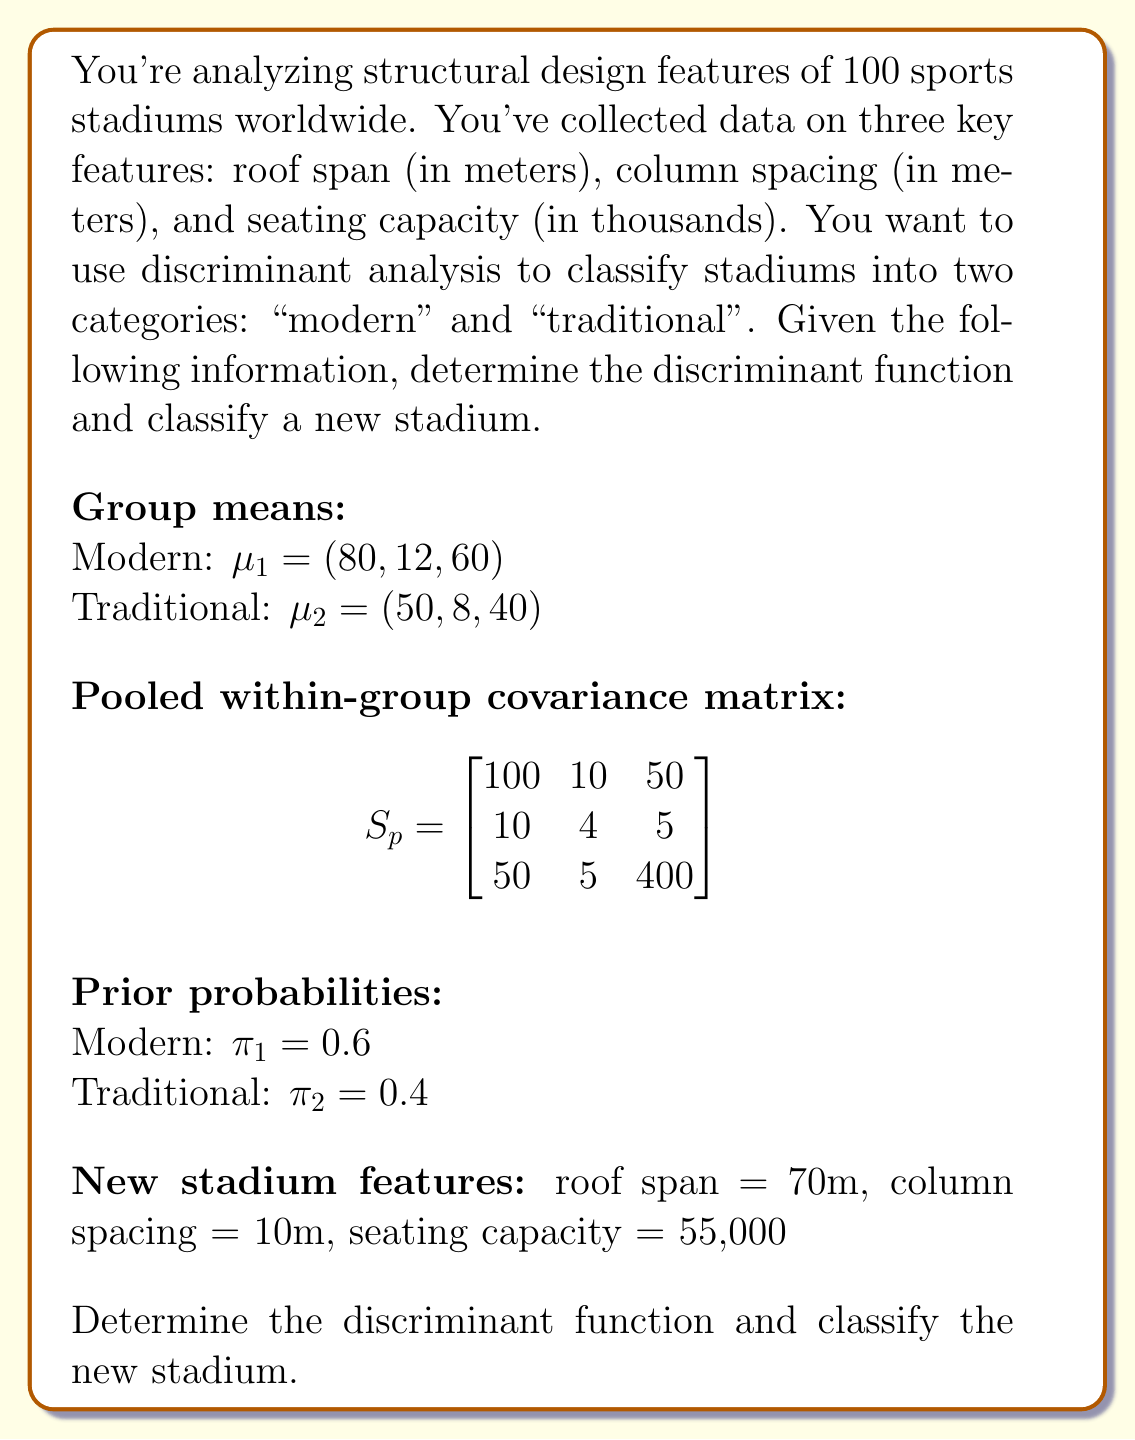Provide a solution to this math problem. To solve this problem, we'll follow these steps:

1) Calculate the discriminant function coefficients
2) Determine the constant term
3) Construct the discriminant function
4) Apply the function to the new stadium data
5) Classify the stadium based on the result

Step 1: Calculate discriminant function coefficients

The discriminant function coefficients are given by:

$a = S_p^{-1}(\mu_1 - \mu_2)$

First, we need to find $S_p^{-1}$:

$$S_p^{-1} = \begin{bmatrix}
0.0107 & -0.0268 & -0.0013 \\
-0.0268 & 0.2634 & 0.0007 \\
-0.0013 & 0.0007 & 0.0026
\end{bmatrix}$$

Now, we can calculate $a$:

$a = \begin{bmatrix}
0.0107 & -0.0268 & -0.0013 \\
-0.0268 & 0.2634 & 0.0007 \\
-0.0013 & 0.0007 & 0.0026
\end{bmatrix} \begin{pmatrix}
30 \\
4 \\
20
\end{pmatrix}$

$a = \begin{pmatrix}
0.1598 \\
0.9470 \\
0.0494
\end{pmatrix}$

Step 2: Determine the constant term

The constant term is given by:

$c = -\frac{1}{2}a'(\mu_1 + \mu_2) + \ln(\frac{\pi_1}{\pi_2})$

$c = -\frac{1}{2}(0.1598 \cdot 130 + 0.9470 \cdot 20 + 0.0494 \cdot 100) + \ln(\frac{0.6}{0.4})$

$c = -13.9850 + 0.4055 = -13.5795$

Step 3: Construct the discriminant function

The discriminant function is:

$D(x) = a'x + c = 0.1598x_1 + 0.9470x_2 + 0.0494x_3 - 13.5795$

Step 4: Apply the function to the new stadium data

For the new stadium: $x = (70, 10, 55)$

$D(x) = 0.1598(70) + 0.9470(10) + 0.0494(55) - 13.5795$
$D(x) = 11.186 + 9.470 + 2.717 - 13.5795 = 9.7935$

Step 5: Classify the stadium

If $D(x) > 0$, classify as modern; if $D(x) < 0$, classify as traditional.

Since $D(x) = 9.7935 > 0$, we classify the new stadium as modern.
Answer: The discriminant function is $D(x) = 0.1598x_1 + 0.9470x_2 + 0.0494x_3 - 13.5795$, where $x_1$ is roof span, $x_2$ is column spacing, and $x_3$ is seating capacity. The new stadium is classified as modern. 